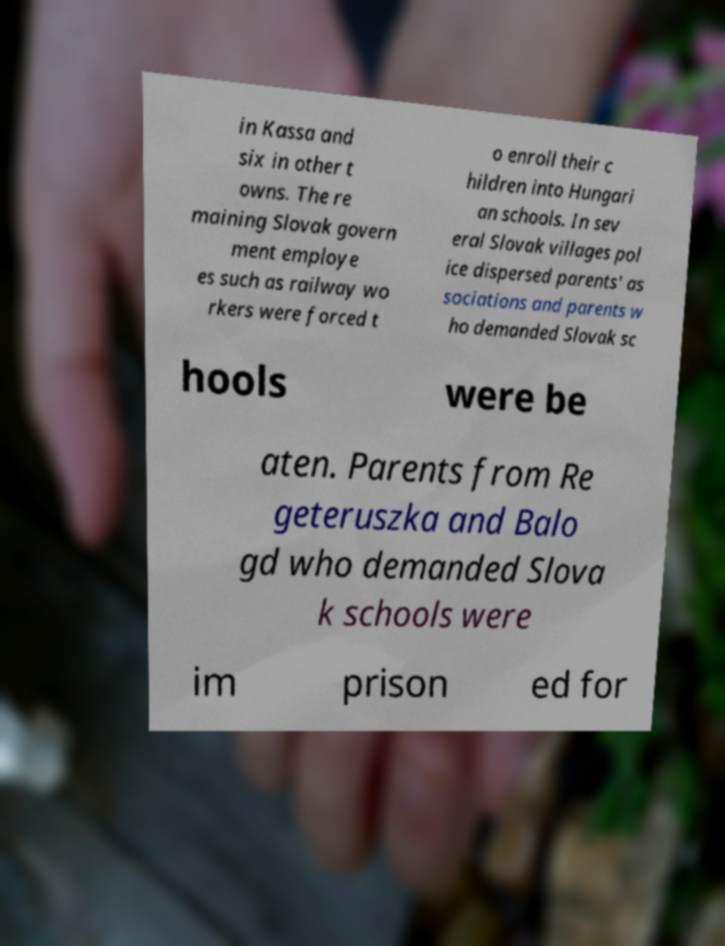Can you accurately transcribe the text from the provided image for me? in Kassa and six in other t owns. The re maining Slovak govern ment employe es such as railway wo rkers were forced t o enroll their c hildren into Hungari an schools. In sev eral Slovak villages pol ice dispersed parents' as sociations and parents w ho demanded Slovak sc hools were be aten. Parents from Re geteruszka and Balo gd who demanded Slova k schools were im prison ed for 